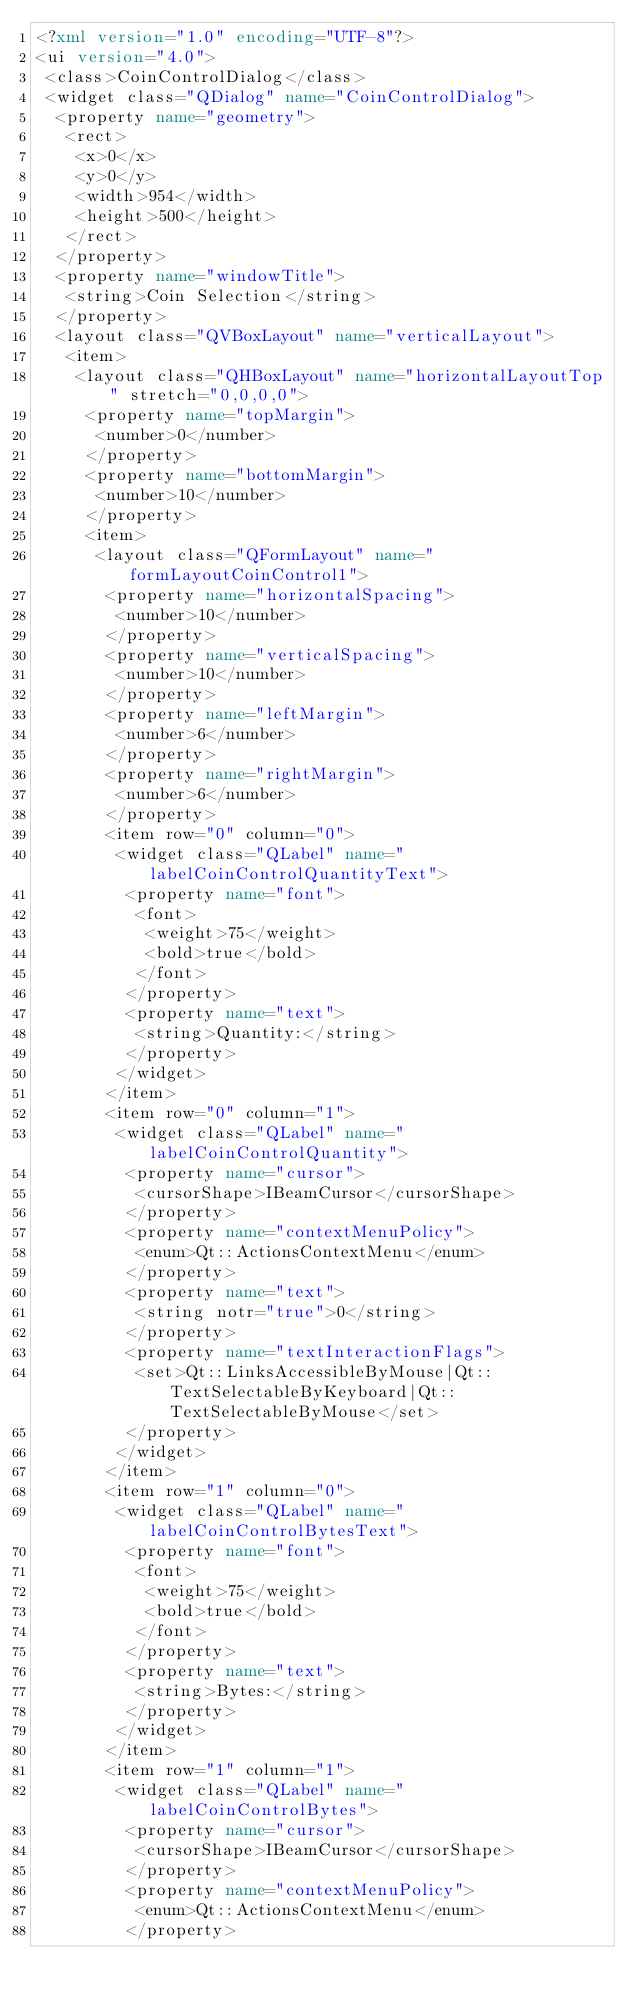<code> <loc_0><loc_0><loc_500><loc_500><_XML_><?xml version="1.0" encoding="UTF-8"?>
<ui version="4.0">
 <class>CoinControlDialog</class>
 <widget class="QDialog" name="CoinControlDialog">
  <property name="geometry">
   <rect>
    <x>0</x>
    <y>0</y>
    <width>954</width>
    <height>500</height>
   </rect>
  </property>
  <property name="windowTitle">
   <string>Coin Selection</string>
  </property>
  <layout class="QVBoxLayout" name="verticalLayout">
   <item>
    <layout class="QHBoxLayout" name="horizontalLayoutTop" stretch="0,0,0,0">
     <property name="topMargin">
      <number>0</number>
     </property>
     <property name="bottomMargin">
      <number>10</number>
     </property>
     <item>
      <layout class="QFormLayout" name="formLayoutCoinControl1">
       <property name="horizontalSpacing">
        <number>10</number>
       </property>
       <property name="verticalSpacing">
        <number>10</number>
       </property>
       <property name="leftMargin">
        <number>6</number>
       </property>
       <property name="rightMargin">
        <number>6</number>
       </property>
       <item row="0" column="0">
        <widget class="QLabel" name="labelCoinControlQuantityText">
         <property name="font">
          <font>
           <weight>75</weight>
           <bold>true</bold>
          </font>
         </property>
         <property name="text">
          <string>Quantity:</string>
         </property>
        </widget>
       </item>
       <item row="0" column="1">
        <widget class="QLabel" name="labelCoinControlQuantity">
         <property name="cursor">
          <cursorShape>IBeamCursor</cursorShape>
         </property>
         <property name="contextMenuPolicy">
          <enum>Qt::ActionsContextMenu</enum>
         </property>
         <property name="text">
          <string notr="true">0</string>
         </property>
         <property name="textInteractionFlags">
          <set>Qt::LinksAccessibleByMouse|Qt::TextSelectableByKeyboard|Qt::TextSelectableByMouse</set>
         </property>
        </widget>
       </item>
       <item row="1" column="0">
        <widget class="QLabel" name="labelCoinControlBytesText">
         <property name="font">
          <font>
           <weight>75</weight>
           <bold>true</bold>
          </font>
         </property>
         <property name="text">
          <string>Bytes:</string>
         </property>
        </widget>
       </item>
       <item row="1" column="1">
        <widget class="QLabel" name="labelCoinControlBytes">
         <property name="cursor">
          <cursorShape>IBeamCursor</cursorShape>
         </property>
         <property name="contextMenuPolicy">
          <enum>Qt::ActionsContextMenu</enum>
         </property></code> 